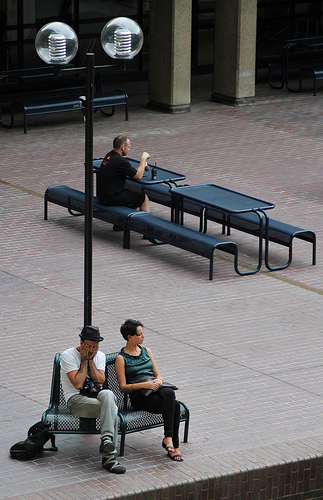Please provide a short description for this region: [0.41, 0.63, 0.54, 0.93]. In the specified region, you can observe a woman dressed in casual attire, comfortably wearing flip-flops as she sits in a relaxed posture. 